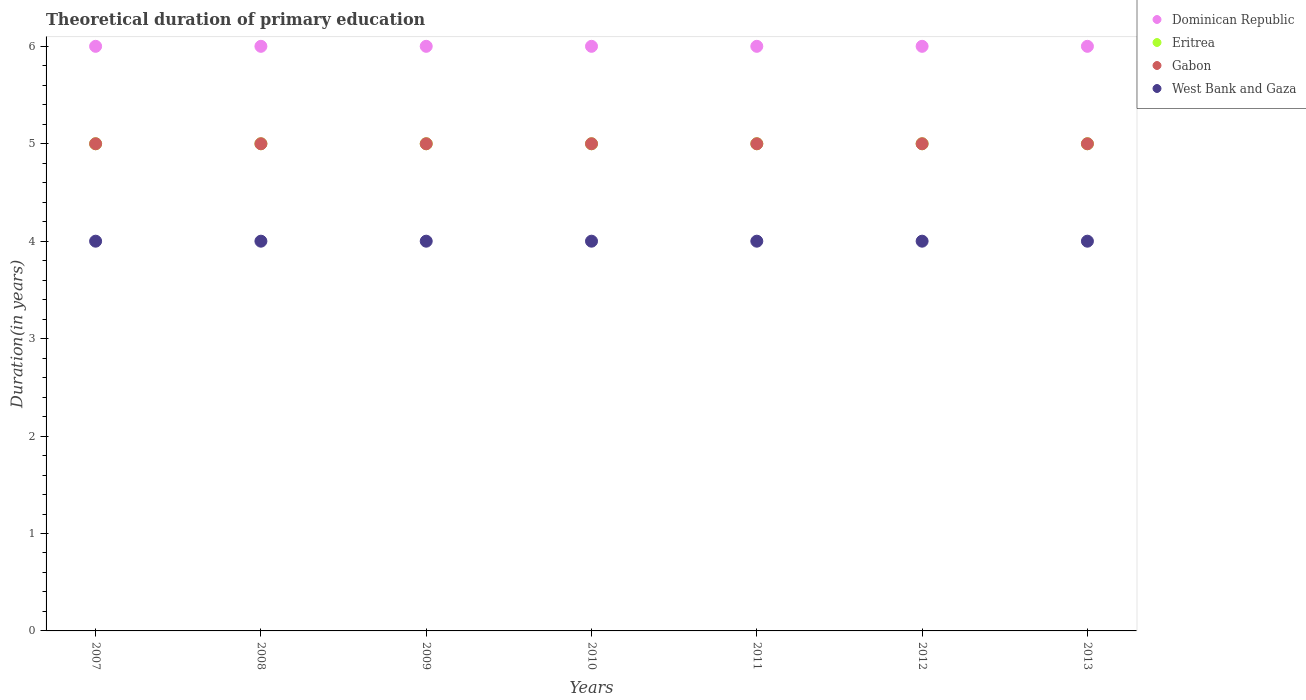Is the number of dotlines equal to the number of legend labels?
Your response must be concise. Yes. What is the total theoretical duration of primary education in Eritrea in 2013?
Make the answer very short. 5. Across all years, what is the minimum total theoretical duration of primary education in Eritrea?
Your response must be concise. 5. In which year was the total theoretical duration of primary education in Dominican Republic maximum?
Offer a terse response. 2007. In which year was the total theoretical duration of primary education in Gabon minimum?
Provide a succinct answer. 2007. What is the total total theoretical duration of primary education in West Bank and Gaza in the graph?
Give a very brief answer. 28. What is the difference between the total theoretical duration of primary education in West Bank and Gaza in 2007 and that in 2013?
Keep it short and to the point. 0. What is the difference between the total theoretical duration of primary education in West Bank and Gaza in 2007 and the total theoretical duration of primary education in Dominican Republic in 2009?
Your response must be concise. -2. What is the average total theoretical duration of primary education in Eritrea per year?
Offer a very short reply. 5. In the year 2009, what is the difference between the total theoretical duration of primary education in Gabon and total theoretical duration of primary education in West Bank and Gaza?
Provide a succinct answer. 1. What is the ratio of the total theoretical duration of primary education in Eritrea in 2011 to that in 2013?
Ensure brevity in your answer.  1. Is the total theoretical duration of primary education in Dominican Republic in 2011 less than that in 2012?
Give a very brief answer. No. What is the difference between the highest and the second highest total theoretical duration of primary education in Dominican Republic?
Give a very brief answer. 0. What is the difference between the highest and the lowest total theoretical duration of primary education in West Bank and Gaza?
Make the answer very short. 0. Is the sum of the total theoretical duration of primary education in Gabon in 2011 and 2013 greater than the maximum total theoretical duration of primary education in Eritrea across all years?
Provide a short and direct response. Yes. Is it the case that in every year, the sum of the total theoretical duration of primary education in Eritrea and total theoretical duration of primary education in Dominican Republic  is greater than the sum of total theoretical duration of primary education in West Bank and Gaza and total theoretical duration of primary education in Gabon?
Give a very brief answer. Yes. Does the total theoretical duration of primary education in West Bank and Gaza monotonically increase over the years?
Make the answer very short. No. Is the total theoretical duration of primary education in Eritrea strictly greater than the total theoretical duration of primary education in Dominican Republic over the years?
Offer a very short reply. No. Is the total theoretical duration of primary education in West Bank and Gaza strictly less than the total theoretical duration of primary education in Gabon over the years?
Provide a succinct answer. Yes. How many dotlines are there?
Provide a succinct answer. 4. How many years are there in the graph?
Keep it short and to the point. 7. Does the graph contain grids?
Ensure brevity in your answer.  No. Where does the legend appear in the graph?
Offer a terse response. Top right. What is the title of the graph?
Ensure brevity in your answer.  Theoretical duration of primary education. Does "Switzerland" appear as one of the legend labels in the graph?
Your answer should be very brief. No. What is the label or title of the Y-axis?
Offer a terse response. Duration(in years). What is the Duration(in years) in Dominican Republic in 2007?
Your answer should be compact. 6. What is the Duration(in years) in Eritrea in 2007?
Ensure brevity in your answer.  5. What is the Duration(in years) in Gabon in 2007?
Keep it short and to the point. 5. What is the Duration(in years) in West Bank and Gaza in 2007?
Keep it short and to the point. 4. What is the Duration(in years) in Eritrea in 2008?
Your answer should be very brief. 5. What is the Duration(in years) in Gabon in 2008?
Offer a very short reply. 5. What is the Duration(in years) in West Bank and Gaza in 2008?
Your answer should be very brief. 4. What is the Duration(in years) of Dominican Republic in 2009?
Offer a terse response. 6. What is the Duration(in years) of Gabon in 2009?
Your answer should be compact. 5. What is the Duration(in years) of Dominican Republic in 2010?
Offer a terse response. 6. What is the Duration(in years) of Gabon in 2010?
Your answer should be compact. 5. What is the Duration(in years) of West Bank and Gaza in 2010?
Your response must be concise. 4. What is the Duration(in years) of Dominican Republic in 2011?
Make the answer very short. 6. What is the Duration(in years) of Eritrea in 2011?
Offer a terse response. 5. What is the Duration(in years) in Gabon in 2011?
Keep it short and to the point. 5. What is the Duration(in years) in West Bank and Gaza in 2011?
Your answer should be very brief. 4. What is the Duration(in years) in Eritrea in 2012?
Give a very brief answer. 5. What is the Duration(in years) of Dominican Republic in 2013?
Offer a terse response. 6. Across all years, what is the maximum Duration(in years) of West Bank and Gaza?
Offer a terse response. 4. Across all years, what is the minimum Duration(in years) of Eritrea?
Offer a terse response. 5. Across all years, what is the minimum Duration(in years) of Gabon?
Provide a succinct answer. 5. What is the difference between the Duration(in years) in Eritrea in 2007 and that in 2008?
Provide a succinct answer. 0. What is the difference between the Duration(in years) of Gabon in 2007 and that in 2008?
Keep it short and to the point. 0. What is the difference between the Duration(in years) of West Bank and Gaza in 2007 and that in 2008?
Give a very brief answer. 0. What is the difference between the Duration(in years) in Dominican Republic in 2007 and that in 2009?
Provide a short and direct response. 0. What is the difference between the Duration(in years) in Eritrea in 2007 and that in 2009?
Keep it short and to the point. 0. What is the difference between the Duration(in years) of Eritrea in 2007 and that in 2010?
Offer a very short reply. 0. What is the difference between the Duration(in years) of Gabon in 2007 and that in 2010?
Offer a very short reply. 0. What is the difference between the Duration(in years) in West Bank and Gaza in 2007 and that in 2010?
Provide a succinct answer. 0. What is the difference between the Duration(in years) of Eritrea in 2007 and that in 2011?
Offer a very short reply. 0. What is the difference between the Duration(in years) of Gabon in 2007 and that in 2011?
Keep it short and to the point. 0. What is the difference between the Duration(in years) in Dominican Republic in 2007 and that in 2012?
Provide a short and direct response. 0. What is the difference between the Duration(in years) of Gabon in 2007 and that in 2012?
Your response must be concise. 0. What is the difference between the Duration(in years) in West Bank and Gaza in 2007 and that in 2012?
Provide a succinct answer. 0. What is the difference between the Duration(in years) in Dominican Republic in 2007 and that in 2013?
Your response must be concise. 0. What is the difference between the Duration(in years) of Eritrea in 2007 and that in 2013?
Keep it short and to the point. 0. What is the difference between the Duration(in years) in Gabon in 2007 and that in 2013?
Offer a terse response. 0. What is the difference between the Duration(in years) of Dominican Republic in 2008 and that in 2009?
Your response must be concise. 0. What is the difference between the Duration(in years) of West Bank and Gaza in 2008 and that in 2009?
Keep it short and to the point. 0. What is the difference between the Duration(in years) in Dominican Republic in 2008 and that in 2010?
Provide a succinct answer. 0. What is the difference between the Duration(in years) of Eritrea in 2008 and that in 2010?
Give a very brief answer. 0. What is the difference between the Duration(in years) of Gabon in 2008 and that in 2010?
Ensure brevity in your answer.  0. What is the difference between the Duration(in years) in Eritrea in 2008 and that in 2011?
Give a very brief answer. 0. What is the difference between the Duration(in years) of West Bank and Gaza in 2008 and that in 2011?
Offer a terse response. 0. What is the difference between the Duration(in years) in Dominican Republic in 2008 and that in 2012?
Provide a short and direct response. 0. What is the difference between the Duration(in years) in Eritrea in 2008 and that in 2012?
Give a very brief answer. 0. What is the difference between the Duration(in years) in Gabon in 2008 and that in 2013?
Your response must be concise. 0. What is the difference between the Duration(in years) in Gabon in 2009 and that in 2010?
Offer a terse response. 0. What is the difference between the Duration(in years) of West Bank and Gaza in 2009 and that in 2010?
Provide a succinct answer. 0. What is the difference between the Duration(in years) in Dominican Republic in 2009 and that in 2011?
Make the answer very short. 0. What is the difference between the Duration(in years) in Eritrea in 2009 and that in 2011?
Provide a short and direct response. 0. What is the difference between the Duration(in years) in West Bank and Gaza in 2009 and that in 2011?
Your answer should be compact. 0. What is the difference between the Duration(in years) in Dominican Republic in 2009 and that in 2012?
Offer a very short reply. 0. What is the difference between the Duration(in years) of Gabon in 2009 and that in 2012?
Provide a short and direct response. 0. What is the difference between the Duration(in years) of Eritrea in 2009 and that in 2013?
Provide a succinct answer. 0. What is the difference between the Duration(in years) in Gabon in 2009 and that in 2013?
Your answer should be very brief. 0. What is the difference between the Duration(in years) in West Bank and Gaza in 2009 and that in 2013?
Give a very brief answer. 0. What is the difference between the Duration(in years) in Dominican Republic in 2010 and that in 2011?
Your answer should be compact. 0. What is the difference between the Duration(in years) in Eritrea in 2010 and that in 2011?
Your response must be concise. 0. What is the difference between the Duration(in years) in Gabon in 2010 and that in 2011?
Make the answer very short. 0. What is the difference between the Duration(in years) of West Bank and Gaza in 2010 and that in 2012?
Make the answer very short. 0. What is the difference between the Duration(in years) of Dominican Republic in 2010 and that in 2013?
Offer a terse response. 0. What is the difference between the Duration(in years) in Eritrea in 2010 and that in 2013?
Make the answer very short. 0. What is the difference between the Duration(in years) of West Bank and Gaza in 2010 and that in 2013?
Make the answer very short. 0. What is the difference between the Duration(in years) in Dominican Republic in 2011 and that in 2012?
Ensure brevity in your answer.  0. What is the difference between the Duration(in years) of Gabon in 2011 and that in 2012?
Give a very brief answer. 0. What is the difference between the Duration(in years) in West Bank and Gaza in 2011 and that in 2013?
Make the answer very short. 0. What is the difference between the Duration(in years) of Eritrea in 2012 and that in 2013?
Make the answer very short. 0. What is the difference between the Duration(in years) in West Bank and Gaza in 2012 and that in 2013?
Make the answer very short. 0. What is the difference between the Duration(in years) of Dominican Republic in 2007 and the Duration(in years) of Eritrea in 2008?
Offer a terse response. 1. What is the difference between the Duration(in years) of Eritrea in 2007 and the Duration(in years) of West Bank and Gaza in 2008?
Keep it short and to the point. 1. What is the difference between the Duration(in years) in Dominican Republic in 2007 and the Duration(in years) in Eritrea in 2009?
Keep it short and to the point. 1. What is the difference between the Duration(in years) in Dominican Republic in 2007 and the Duration(in years) in West Bank and Gaza in 2009?
Your answer should be compact. 2. What is the difference between the Duration(in years) in Eritrea in 2007 and the Duration(in years) in Gabon in 2009?
Make the answer very short. 0. What is the difference between the Duration(in years) of Eritrea in 2007 and the Duration(in years) of West Bank and Gaza in 2009?
Keep it short and to the point. 1. What is the difference between the Duration(in years) in Gabon in 2007 and the Duration(in years) in West Bank and Gaza in 2009?
Provide a short and direct response. 1. What is the difference between the Duration(in years) in Eritrea in 2007 and the Duration(in years) in West Bank and Gaza in 2010?
Make the answer very short. 1. What is the difference between the Duration(in years) of Dominican Republic in 2007 and the Duration(in years) of Eritrea in 2011?
Offer a terse response. 1. What is the difference between the Duration(in years) of Dominican Republic in 2007 and the Duration(in years) of Gabon in 2011?
Your response must be concise. 1. What is the difference between the Duration(in years) of Dominican Republic in 2007 and the Duration(in years) of West Bank and Gaza in 2011?
Ensure brevity in your answer.  2. What is the difference between the Duration(in years) in Eritrea in 2007 and the Duration(in years) in West Bank and Gaza in 2011?
Give a very brief answer. 1. What is the difference between the Duration(in years) in Dominican Republic in 2007 and the Duration(in years) in Eritrea in 2012?
Make the answer very short. 1. What is the difference between the Duration(in years) of Dominican Republic in 2007 and the Duration(in years) of Gabon in 2012?
Your answer should be compact. 1. What is the difference between the Duration(in years) in Dominican Republic in 2007 and the Duration(in years) in West Bank and Gaza in 2012?
Make the answer very short. 2. What is the difference between the Duration(in years) of Eritrea in 2007 and the Duration(in years) of Gabon in 2012?
Offer a very short reply. 0. What is the difference between the Duration(in years) of Gabon in 2007 and the Duration(in years) of West Bank and Gaza in 2012?
Your answer should be very brief. 1. What is the difference between the Duration(in years) in Dominican Republic in 2007 and the Duration(in years) in Gabon in 2013?
Your answer should be very brief. 1. What is the difference between the Duration(in years) of Gabon in 2007 and the Duration(in years) of West Bank and Gaza in 2013?
Ensure brevity in your answer.  1. What is the difference between the Duration(in years) in Dominican Republic in 2008 and the Duration(in years) in Eritrea in 2009?
Make the answer very short. 1. What is the difference between the Duration(in years) in Dominican Republic in 2008 and the Duration(in years) in Gabon in 2009?
Your response must be concise. 1. What is the difference between the Duration(in years) in Dominican Republic in 2008 and the Duration(in years) in West Bank and Gaza in 2009?
Keep it short and to the point. 2. What is the difference between the Duration(in years) in Eritrea in 2008 and the Duration(in years) in West Bank and Gaza in 2009?
Offer a terse response. 1. What is the difference between the Duration(in years) of Gabon in 2008 and the Duration(in years) of West Bank and Gaza in 2009?
Provide a short and direct response. 1. What is the difference between the Duration(in years) in Dominican Republic in 2008 and the Duration(in years) in Eritrea in 2010?
Provide a short and direct response. 1. What is the difference between the Duration(in years) of Dominican Republic in 2008 and the Duration(in years) of West Bank and Gaza in 2010?
Give a very brief answer. 2. What is the difference between the Duration(in years) in Dominican Republic in 2008 and the Duration(in years) in Eritrea in 2011?
Provide a short and direct response. 1. What is the difference between the Duration(in years) in Dominican Republic in 2008 and the Duration(in years) in West Bank and Gaza in 2011?
Offer a terse response. 2. What is the difference between the Duration(in years) in Gabon in 2008 and the Duration(in years) in West Bank and Gaza in 2011?
Your answer should be very brief. 1. What is the difference between the Duration(in years) of Dominican Republic in 2008 and the Duration(in years) of Gabon in 2012?
Your response must be concise. 1. What is the difference between the Duration(in years) of Dominican Republic in 2008 and the Duration(in years) of West Bank and Gaza in 2012?
Your answer should be compact. 2. What is the difference between the Duration(in years) of Eritrea in 2008 and the Duration(in years) of Gabon in 2012?
Your answer should be compact. 0. What is the difference between the Duration(in years) in Eritrea in 2008 and the Duration(in years) in West Bank and Gaza in 2012?
Provide a succinct answer. 1. What is the difference between the Duration(in years) in Dominican Republic in 2008 and the Duration(in years) in Gabon in 2013?
Provide a short and direct response. 1. What is the difference between the Duration(in years) in Dominican Republic in 2009 and the Duration(in years) in Eritrea in 2010?
Give a very brief answer. 1. What is the difference between the Duration(in years) of Dominican Republic in 2009 and the Duration(in years) of Gabon in 2010?
Your answer should be very brief. 1. What is the difference between the Duration(in years) in Dominican Republic in 2009 and the Duration(in years) in Eritrea in 2011?
Your answer should be very brief. 1. What is the difference between the Duration(in years) of Dominican Republic in 2009 and the Duration(in years) of Gabon in 2011?
Offer a very short reply. 1. What is the difference between the Duration(in years) of Dominican Republic in 2009 and the Duration(in years) of West Bank and Gaza in 2011?
Give a very brief answer. 2. What is the difference between the Duration(in years) in Eritrea in 2009 and the Duration(in years) in Gabon in 2011?
Ensure brevity in your answer.  0. What is the difference between the Duration(in years) in Eritrea in 2009 and the Duration(in years) in Gabon in 2012?
Your answer should be very brief. 0. What is the difference between the Duration(in years) in Eritrea in 2009 and the Duration(in years) in West Bank and Gaza in 2012?
Your response must be concise. 1. What is the difference between the Duration(in years) of Dominican Republic in 2009 and the Duration(in years) of West Bank and Gaza in 2013?
Your response must be concise. 2. What is the difference between the Duration(in years) in Eritrea in 2009 and the Duration(in years) in Gabon in 2013?
Ensure brevity in your answer.  0. What is the difference between the Duration(in years) in Eritrea in 2010 and the Duration(in years) in West Bank and Gaza in 2011?
Make the answer very short. 1. What is the difference between the Duration(in years) in Dominican Republic in 2010 and the Duration(in years) in Gabon in 2012?
Ensure brevity in your answer.  1. What is the difference between the Duration(in years) in Dominican Republic in 2010 and the Duration(in years) in West Bank and Gaza in 2012?
Provide a succinct answer. 2. What is the difference between the Duration(in years) in Eritrea in 2010 and the Duration(in years) in Gabon in 2012?
Keep it short and to the point. 0. What is the difference between the Duration(in years) of Eritrea in 2010 and the Duration(in years) of West Bank and Gaza in 2012?
Keep it short and to the point. 1. What is the difference between the Duration(in years) of Gabon in 2010 and the Duration(in years) of West Bank and Gaza in 2012?
Offer a terse response. 1. What is the difference between the Duration(in years) in Dominican Republic in 2010 and the Duration(in years) in Gabon in 2013?
Provide a succinct answer. 1. What is the difference between the Duration(in years) in Eritrea in 2010 and the Duration(in years) in Gabon in 2013?
Make the answer very short. 0. What is the difference between the Duration(in years) of Gabon in 2010 and the Duration(in years) of West Bank and Gaza in 2013?
Provide a short and direct response. 1. What is the difference between the Duration(in years) in Dominican Republic in 2011 and the Duration(in years) in Eritrea in 2012?
Give a very brief answer. 1. What is the difference between the Duration(in years) in Dominican Republic in 2011 and the Duration(in years) in West Bank and Gaza in 2012?
Your answer should be compact. 2. What is the difference between the Duration(in years) in Eritrea in 2011 and the Duration(in years) in Gabon in 2012?
Keep it short and to the point. 0. What is the difference between the Duration(in years) of Dominican Republic in 2011 and the Duration(in years) of Eritrea in 2013?
Your response must be concise. 1. What is the difference between the Duration(in years) in Dominican Republic in 2011 and the Duration(in years) in West Bank and Gaza in 2013?
Provide a succinct answer. 2. What is the difference between the Duration(in years) in Gabon in 2011 and the Duration(in years) in West Bank and Gaza in 2013?
Make the answer very short. 1. What is the difference between the Duration(in years) in Dominican Republic in 2012 and the Duration(in years) in Eritrea in 2013?
Ensure brevity in your answer.  1. What is the difference between the Duration(in years) in Dominican Republic in 2012 and the Duration(in years) in Gabon in 2013?
Offer a very short reply. 1. What is the difference between the Duration(in years) of Gabon in 2012 and the Duration(in years) of West Bank and Gaza in 2013?
Provide a short and direct response. 1. What is the average Duration(in years) of Dominican Republic per year?
Your response must be concise. 6. What is the average Duration(in years) in Eritrea per year?
Keep it short and to the point. 5. What is the average Duration(in years) of Gabon per year?
Your response must be concise. 5. What is the average Duration(in years) of West Bank and Gaza per year?
Offer a terse response. 4. In the year 2007, what is the difference between the Duration(in years) in Dominican Republic and Duration(in years) in West Bank and Gaza?
Your response must be concise. 2. In the year 2007, what is the difference between the Duration(in years) of Gabon and Duration(in years) of West Bank and Gaza?
Ensure brevity in your answer.  1. In the year 2008, what is the difference between the Duration(in years) of Dominican Republic and Duration(in years) of West Bank and Gaza?
Make the answer very short. 2. In the year 2009, what is the difference between the Duration(in years) of Dominican Republic and Duration(in years) of West Bank and Gaza?
Ensure brevity in your answer.  2. In the year 2009, what is the difference between the Duration(in years) in Eritrea and Duration(in years) in West Bank and Gaza?
Provide a short and direct response. 1. In the year 2009, what is the difference between the Duration(in years) in Gabon and Duration(in years) in West Bank and Gaza?
Offer a very short reply. 1. In the year 2010, what is the difference between the Duration(in years) of Dominican Republic and Duration(in years) of Eritrea?
Give a very brief answer. 1. In the year 2010, what is the difference between the Duration(in years) of Dominican Republic and Duration(in years) of Gabon?
Provide a succinct answer. 1. In the year 2010, what is the difference between the Duration(in years) of Eritrea and Duration(in years) of West Bank and Gaza?
Ensure brevity in your answer.  1. In the year 2011, what is the difference between the Duration(in years) of Eritrea and Duration(in years) of Gabon?
Offer a terse response. 0. In the year 2011, what is the difference between the Duration(in years) of Eritrea and Duration(in years) of West Bank and Gaza?
Offer a very short reply. 1. In the year 2011, what is the difference between the Duration(in years) in Gabon and Duration(in years) in West Bank and Gaza?
Provide a succinct answer. 1. In the year 2012, what is the difference between the Duration(in years) of Dominican Republic and Duration(in years) of Gabon?
Your response must be concise. 1. In the year 2012, what is the difference between the Duration(in years) in Eritrea and Duration(in years) in West Bank and Gaza?
Ensure brevity in your answer.  1. In the year 2013, what is the difference between the Duration(in years) of Dominican Republic and Duration(in years) of Gabon?
Keep it short and to the point. 1. In the year 2013, what is the difference between the Duration(in years) in Eritrea and Duration(in years) in West Bank and Gaza?
Give a very brief answer. 1. In the year 2013, what is the difference between the Duration(in years) of Gabon and Duration(in years) of West Bank and Gaza?
Offer a very short reply. 1. What is the ratio of the Duration(in years) in Dominican Republic in 2007 to that in 2008?
Your answer should be very brief. 1. What is the ratio of the Duration(in years) in Eritrea in 2007 to that in 2008?
Provide a short and direct response. 1. What is the ratio of the Duration(in years) in Gabon in 2007 to that in 2008?
Keep it short and to the point. 1. What is the ratio of the Duration(in years) of Dominican Republic in 2007 to that in 2009?
Your answer should be compact. 1. What is the ratio of the Duration(in years) in Eritrea in 2007 to that in 2009?
Your response must be concise. 1. What is the ratio of the Duration(in years) in Gabon in 2007 to that in 2009?
Your response must be concise. 1. What is the ratio of the Duration(in years) of Eritrea in 2007 to that in 2010?
Provide a succinct answer. 1. What is the ratio of the Duration(in years) in Eritrea in 2007 to that in 2011?
Your answer should be very brief. 1. What is the ratio of the Duration(in years) of Gabon in 2007 to that in 2011?
Ensure brevity in your answer.  1. What is the ratio of the Duration(in years) of Dominican Republic in 2007 to that in 2012?
Ensure brevity in your answer.  1. What is the ratio of the Duration(in years) in Eritrea in 2007 to that in 2012?
Offer a very short reply. 1. What is the ratio of the Duration(in years) in Gabon in 2007 to that in 2012?
Your response must be concise. 1. What is the ratio of the Duration(in years) in Dominican Republic in 2008 to that in 2010?
Provide a succinct answer. 1. What is the ratio of the Duration(in years) in Eritrea in 2008 to that in 2010?
Give a very brief answer. 1. What is the ratio of the Duration(in years) in West Bank and Gaza in 2008 to that in 2010?
Keep it short and to the point. 1. What is the ratio of the Duration(in years) of Gabon in 2008 to that in 2011?
Offer a very short reply. 1. What is the ratio of the Duration(in years) in West Bank and Gaza in 2008 to that in 2011?
Keep it short and to the point. 1. What is the ratio of the Duration(in years) of West Bank and Gaza in 2008 to that in 2013?
Offer a very short reply. 1. What is the ratio of the Duration(in years) in Dominican Republic in 2009 to that in 2010?
Offer a very short reply. 1. What is the ratio of the Duration(in years) in Eritrea in 2009 to that in 2010?
Offer a terse response. 1. What is the ratio of the Duration(in years) in Gabon in 2009 to that in 2010?
Your answer should be very brief. 1. What is the ratio of the Duration(in years) of West Bank and Gaza in 2009 to that in 2010?
Make the answer very short. 1. What is the ratio of the Duration(in years) in Dominican Republic in 2009 to that in 2011?
Ensure brevity in your answer.  1. What is the ratio of the Duration(in years) of Eritrea in 2009 to that in 2011?
Give a very brief answer. 1. What is the ratio of the Duration(in years) in Dominican Republic in 2009 to that in 2012?
Your response must be concise. 1. What is the ratio of the Duration(in years) of Eritrea in 2009 to that in 2012?
Ensure brevity in your answer.  1. What is the ratio of the Duration(in years) of Dominican Republic in 2009 to that in 2013?
Offer a very short reply. 1. What is the ratio of the Duration(in years) in Eritrea in 2009 to that in 2013?
Offer a very short reply. 1. What is the ratio of the Duration(in years) of Dominican Republic in 2010 to that in 2011?
Provide a succinct answer. 1. What is the ratio of the Duration(in years) of Eritrea in 2010 to that in 2011?
Your response must be concise. 1. What is the ratio of the Duration(in years) of Gabon in 2010 to that in 2011?
Provide a succinct answer. 1. What is the ratio of the Duration(in years) in West Bank and Gaza in 2010 to that in 2011?
Your answer should be very brief. 1. What is the ratio of the Duration(in years) of Dominican Republic in 2010 to that in 2012?
Ensure brevity in your answer.  1. What is the ratio of the Duration(in years) of Eritrea in 2010 to that in 2012?
Your response must be concise. 1. What is the ratio of the Duration(in years) of Eritrea in 2010 to that in 2013?
Offer a terse response. 1. What is the ratio of the Duration(in years) in Gabon in 2010 to that in 2013?
Offer a terse response. 1. What is the ratio of the Duration(in years) of West Bank and Gaza in 2010 to that in 2013?
Provide a short and direct response. 1. What is the ratio of the Duration(in years) in Dominican Republic in 2011 to that in 2012?
Keep it short and to the point. 1. What is the ratio of the Duration(in years) of Eritrea in 2011 to that in 2012?
Provide a succinct answer. 1. What is the ratio of the Duration(in years) of Gabon in 2011 to that in 2012?
Keep it short and to the point. 1. What is the ratio of the Duration(in years) of West Bank and Gaza in 2011 to that in 2012?
Offer a terse response. 1. What is the ratio of the Duration(in years) of West Bank and Gaza in 2012 to that in 2013?
Give a very brief answer. 1. What is the difference between the highest and the second highest Duration(in years) in Eritrea?
Your answer should be very brief. 0. What is the difference between the highest and the lowest Duration(in years) in Eritrea?
Your answer should be compact. 0. What is the difference between the highest and the lowest Duration(in years) in Gabon?
Give a very brief answer. 0. 